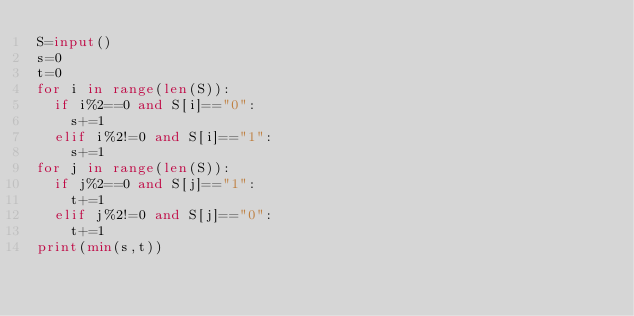<code> <loc_0><loc_0><loc_500><loc_500><_Python_>S=input()
s=0
t=0
for i in range(len(S)):
  if i%2==0 and S[i]=="0":
    s+=1
  elif i%2!=0 and S[i]=="1":
    s+=1
for j in range(len(S)):
  if j%2==0 and S[j]=="1":
    t+=1
  elif j%2!=0 and S[j]=="0":
    t+=1
print(min(s,t))</code> 